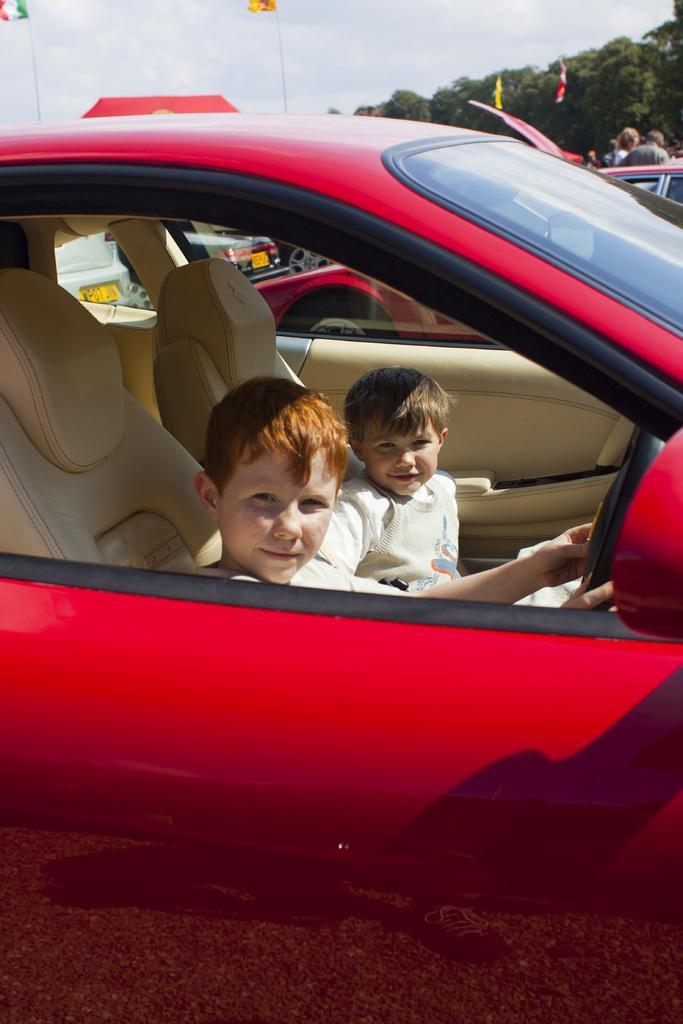Could you give a brief overview of what you see in this image? In this picture there are two kids sitting in the seats of a red colored car. In the background there are some trees and a sky here. 